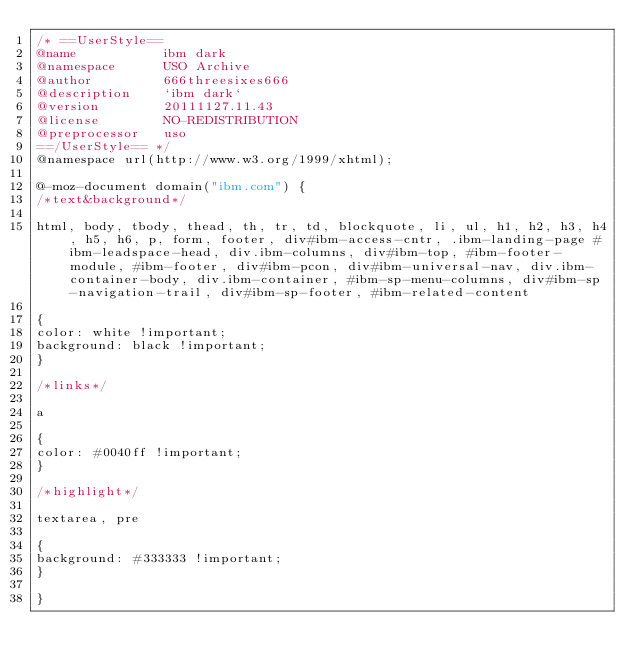Convert code to text. <code><loc_0><loc_0><loc_500><loc_500><_CSS_>/* ==UserStyle==
@name           ibm dark
@namespace      USO Archive
@author         666threesixes666
@description    `ibm dark`
@version        20111127.11.43
@license        NO-REDISTRIBUTION
@preprocessor   uso
==/UserStyle== */
@namespace url(http://www.w3.org/1999/xhtml);

@-moz-document domain("ibm.com") {
/*text&background*/

html, body, tbody, thead, th, tr, td, blockquote, li, ul, h1, h2, h3, h4, h5, h6, p, form, footer, div#ibm-access-cntr, .ibm-landing-page #ibm-leadspace-head, div.ibm-columns, div#ibm-top, #ibm-footer-module, #ibm-footer, div#ibm-pcon, div#ibm-universal-nav, div.ibm-container-body, div.ibm-container, #ibm-sp-menu-columns, div#ibm-sp-navigation-trail, div#ibm-sp-footer, #ibm-related-content

{
color: white !important;
background: black !important;
}

/*links*/

a

{
color: #0040ff !important;
}

/*highlight*/

textarea, pre

{
background: #333333 !important;
}

}</code> 